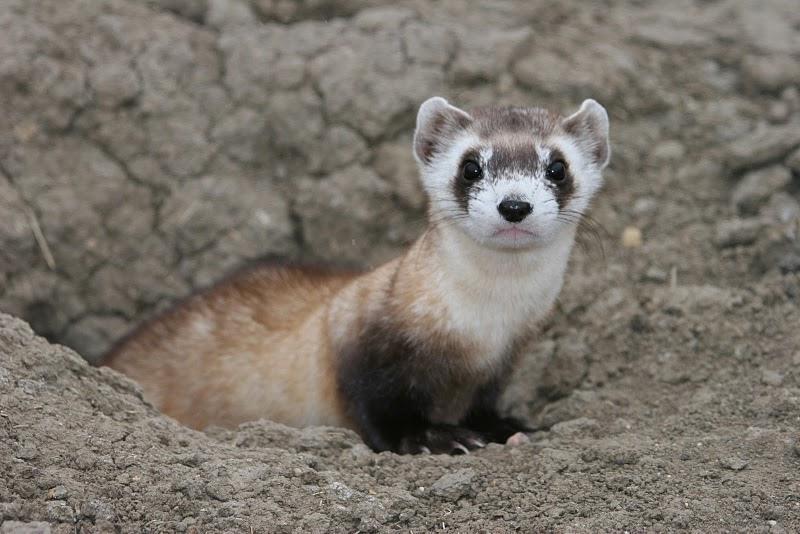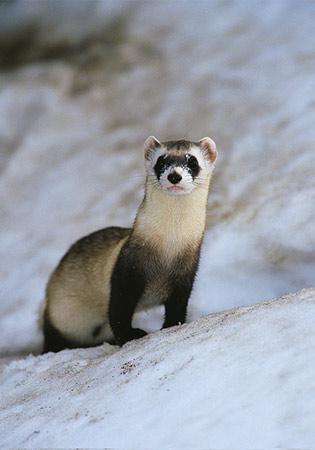The first image is the image on the left, the second image is the image on the right. Assess this claim about the two images: "There is one ferret emerging from a hole and another ferret standing on some dirt.". Correct or not? Answer yes or no. No. The first image is the image on the left, the second image is the image on the right. Given the left and right images, does the statement "A ferret is popping up through a hole inside a metal wire cage." hold true? Answer yes or no. No. 